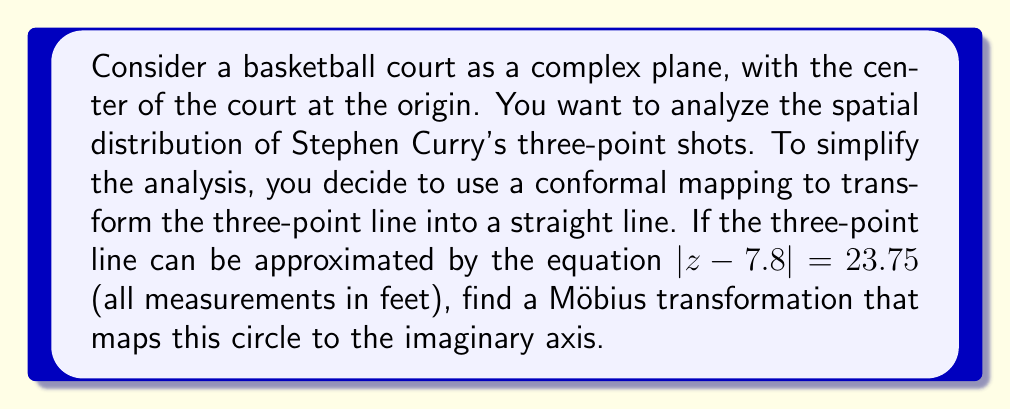Give your solution to this math problem. Let's approach this step-by-step:

1) The general form of a Möbius transformation is:

   $$w = \frac{az + b}{cz + d}$$

   where $a$, $b$, $c$, and $d$ are complex constants with $ad - bc \neq 0$.

2) To map a circle to a straight line, we need to map three points:
   - The center of the circle to infinity
   - Two points on opposite ends of a diameter to points equidistant from the origin on the imaginary axis

3) The center of our circle is at $z = 7.8$. To map this to infinity, we need:

   $$c(7.8) + d = 0$$
   $$c = -\frac{d}{7.8}$$

4) Let's choose two points on the circle. We can use $z_1 = 7.8 + 23.75$ and $z_2 = 7.8 - 23.75$:

   $$z_1 = 31.55$$
   $$z_2 = -15.95$$

5) We want to map these to $i$ and $-i$ respectively. This gives us two equations:

   $$\frac{a(31.55) + b}{c(31.55) + d} = i$$
   $$\frac{a(-15.95) + b}{c(-15.95) + d} = -i$$

6) Substituting $c = -\frac{d}{7.8}$ into these equations and simplifying:

   $$\frac{a(31.55) + b}{-\frac{d}{7.8}(31.55) + d} = i$$
   $$\frac{a(-15.95) + b}{-\frac{d}{7.8}(-15.95) + d} = -i$$

7) These equations are satisfied when:

   $$a = d$$
   $$b = -7.8d$$

8) The specific values of $a$ and $d$ don't matter as long as they're not zero. Let's choose $d = 1$ for simplicity.

Therefore, our Möbius transformation is:

$$w = \frac{z - 7.8}{-\frac{1}{7.8}z + 1}$$
Answer: $$w = \frac{z - 7.8}{-\frac{1}{7.8}z + 1}$$ 